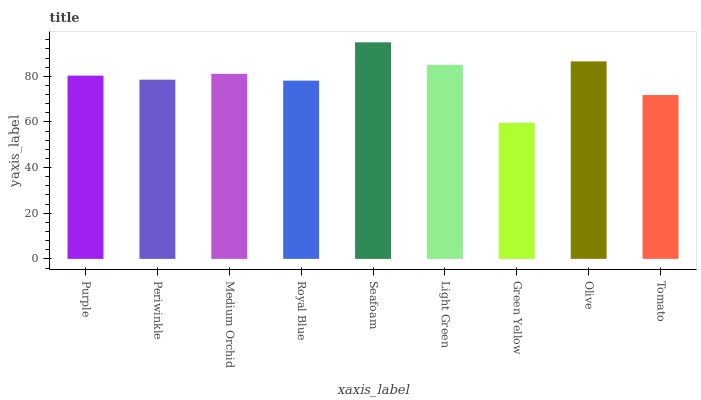Is Periwinkle the minimum?
Answer yes or no. No. Is Periwinkle the maximum?
Answer yes or no. No. Is Purple greater than Periwinkle?
Answer yes or no. Yes. Is Periwinkle less than Purple?
Answer yes or no. Yes. Is Periwinkle greater than Purple?
Answer yes or no. No. Is Purple less than Periwinkle?
Answer yes or no. No. Is Purple the high median?
Answer yes or no. Yes. Is Purple the low median?
Answer yes or no. Yes. Is Periwinkle the high median?
Answer yes or no. No. Is Olive the low median?
Answer yes or no. No. 